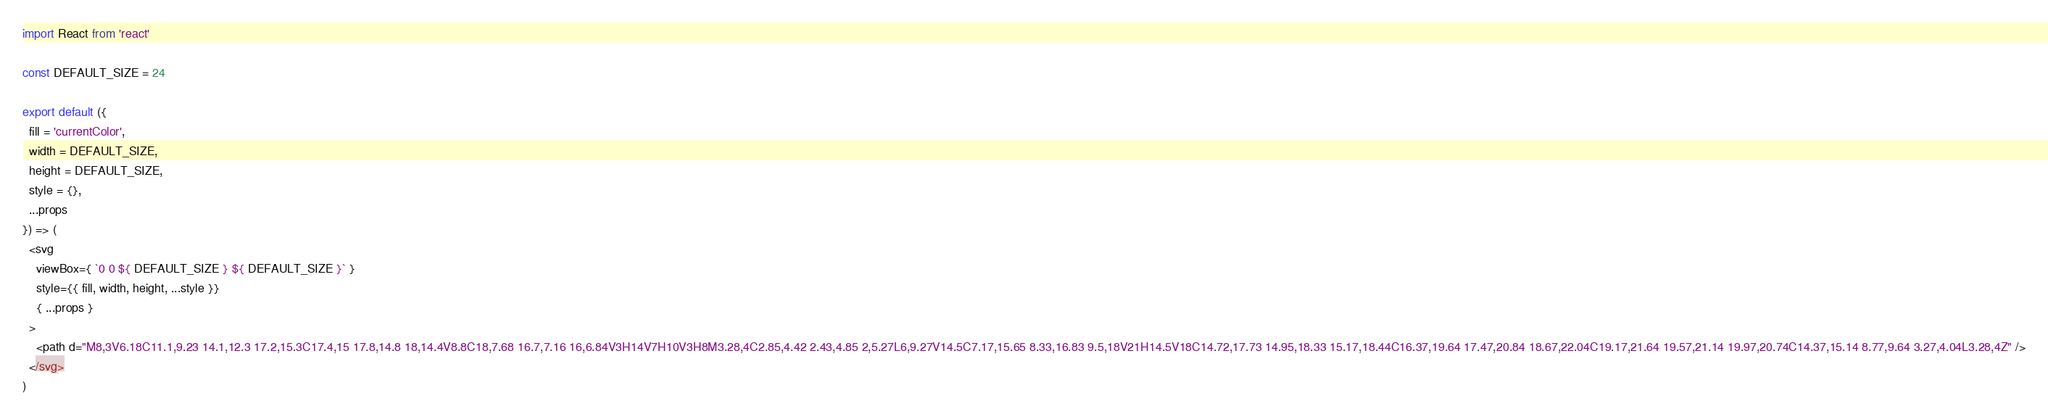<code> <loc_0><loc_0><loc_500><loc_500><_JavaScript_>import React from 'react'

const DEFAULT_SIZE = 24

export default ({
  fill = 'currentColor',
  width = DEFAULT_SIZE,
  height = DEFAULT_SIZE,
  style = {},
  ...props
}) => (
  <svg
    viewBox={ `0 0 ${ DEFAULT_SIZE } ${ DEFAULT_SIZE }` }
    style={{ fill, width, height, ...style }}
    { ...props }
  >
    <path d="M8,3V6.18C11.1,9.23 14.1,12.3 17.2,15.3C17.4,15 17.8,14.8 18,14.4V8.8C18,7.68 16.7,7.16 16,6.84V3H14V7H10V3H8M3.28,4C2.85,4.42 2.43,4.85 2,5.27L6,9.27V14.5C7.17,15.65 8.33,16.83 9.5,18V21H14.5V18C14.72,17.73 14.95,18.33 15.17,18.44C16.37,19.64 17.47,20.84 18.67,22.04C19.17,21.64 19.57,21.14 19.97,20.74C14.37,15.14 8.77,9.64 3.27,4.04L3.28,4Z" />
  </svg>
)
</code> 